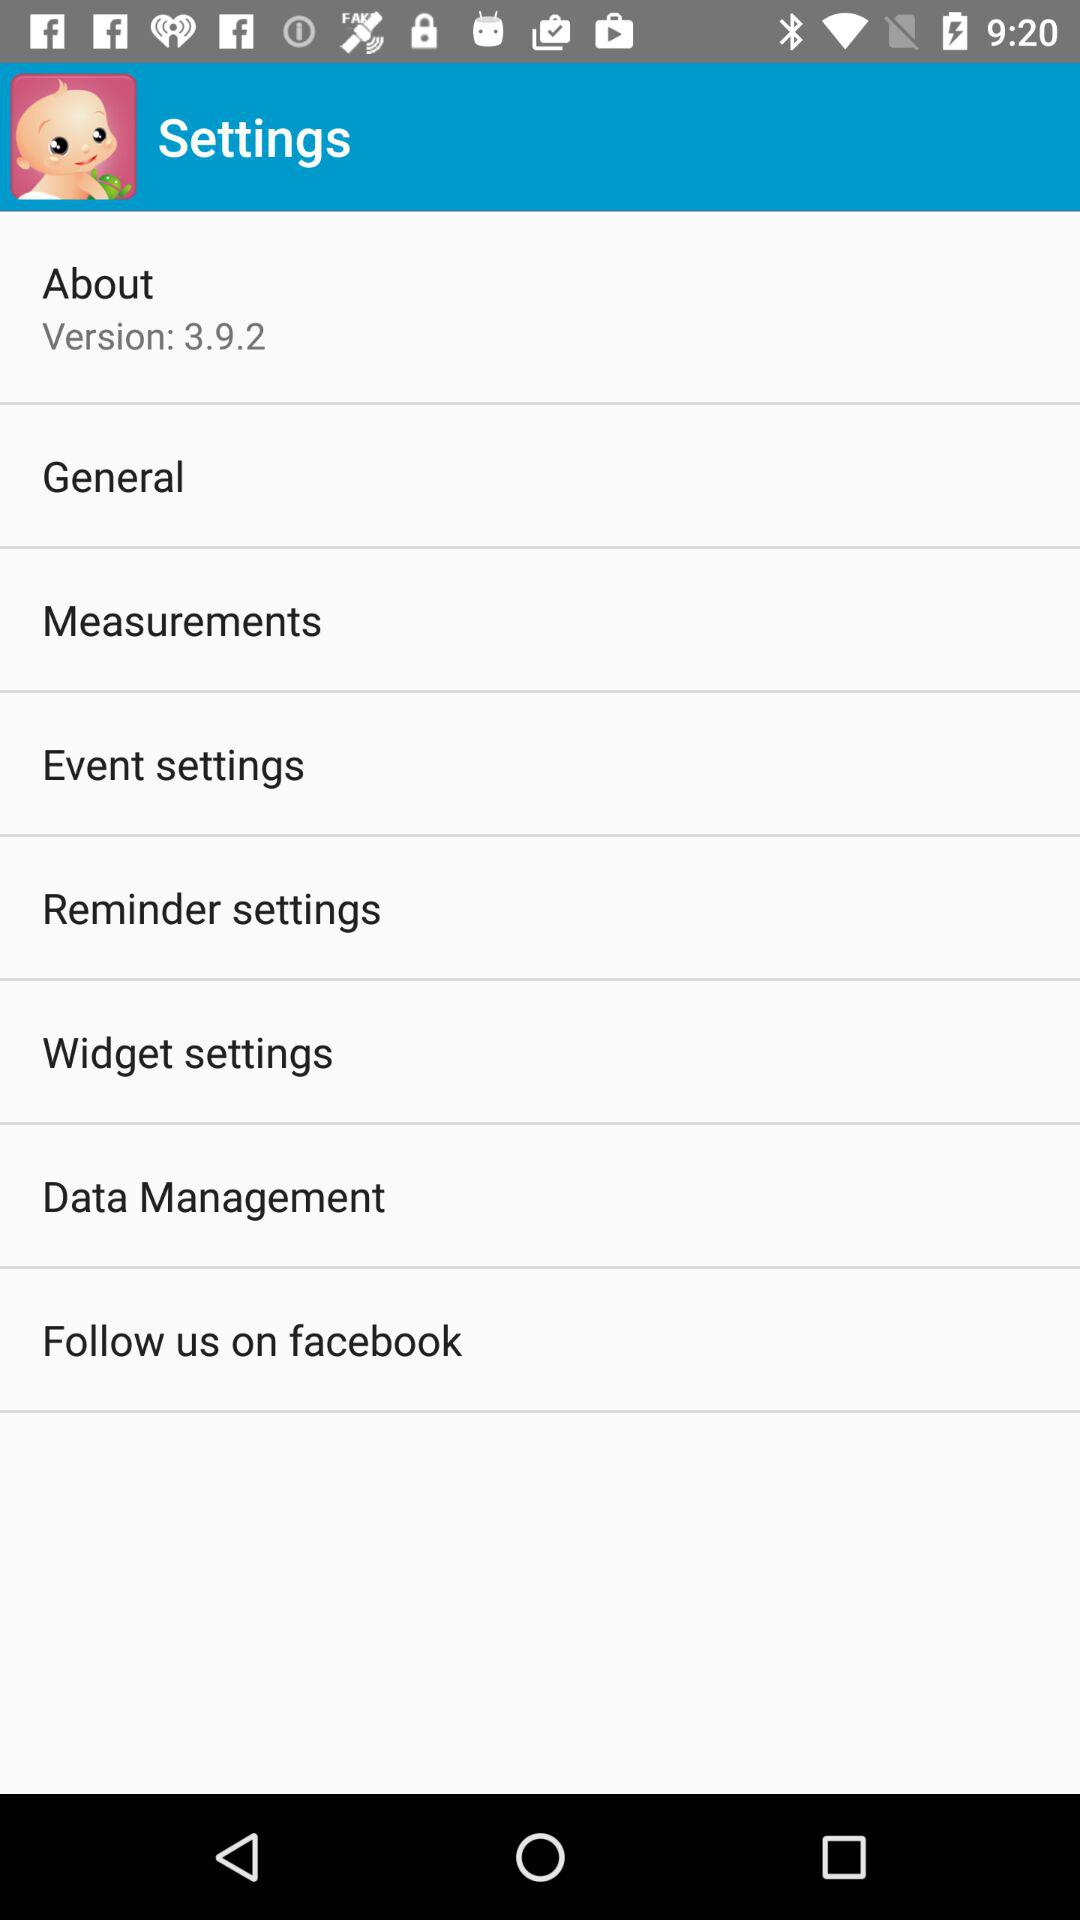What is the version? The version is 3.9.2. 